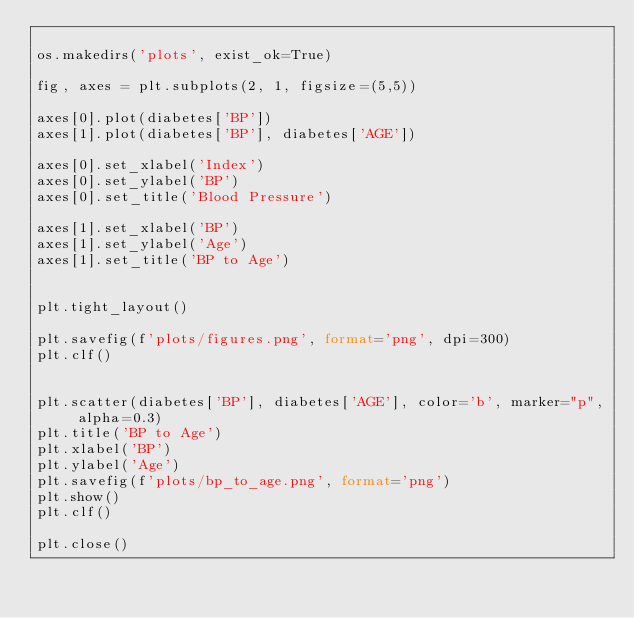<code> <loc_0><loc_0><loc_500><loc_500><_Python_>
os.makedirs('plots', exist_ok=True)

fig, axes = plt.subplots(2, 1, figsize=(5,5))

axes[0].plot(diabetes['BP'])
axes[1].plot(diabetes['BP'], diabetes['AGE'])

axes[0].set_xlabel('Index')
axes[0].set_ylabel('BP')
axes[0].set_title('Blood Pressure')

axes[1].set_xlabel('BP')
axes[1].set_ylabel('Age')
axes[1].set_title('BP to Age')


plt.tight_layout()

plt.savefig(f'plots/figures.png', format='png', dpi=300)
plt.clf()


plt.scatter(diabetes['BP'], diabetes['AGE'], color='b', marker="p", alpha=0.3)
plt.title('BP to Age')
plt.xlabel('BP')
plt.ylabel('Age')
plt.savefig(f'plots/bp_to_age.png', format='png')
plt.show()
plt.clf()

plt.close()

</code> 